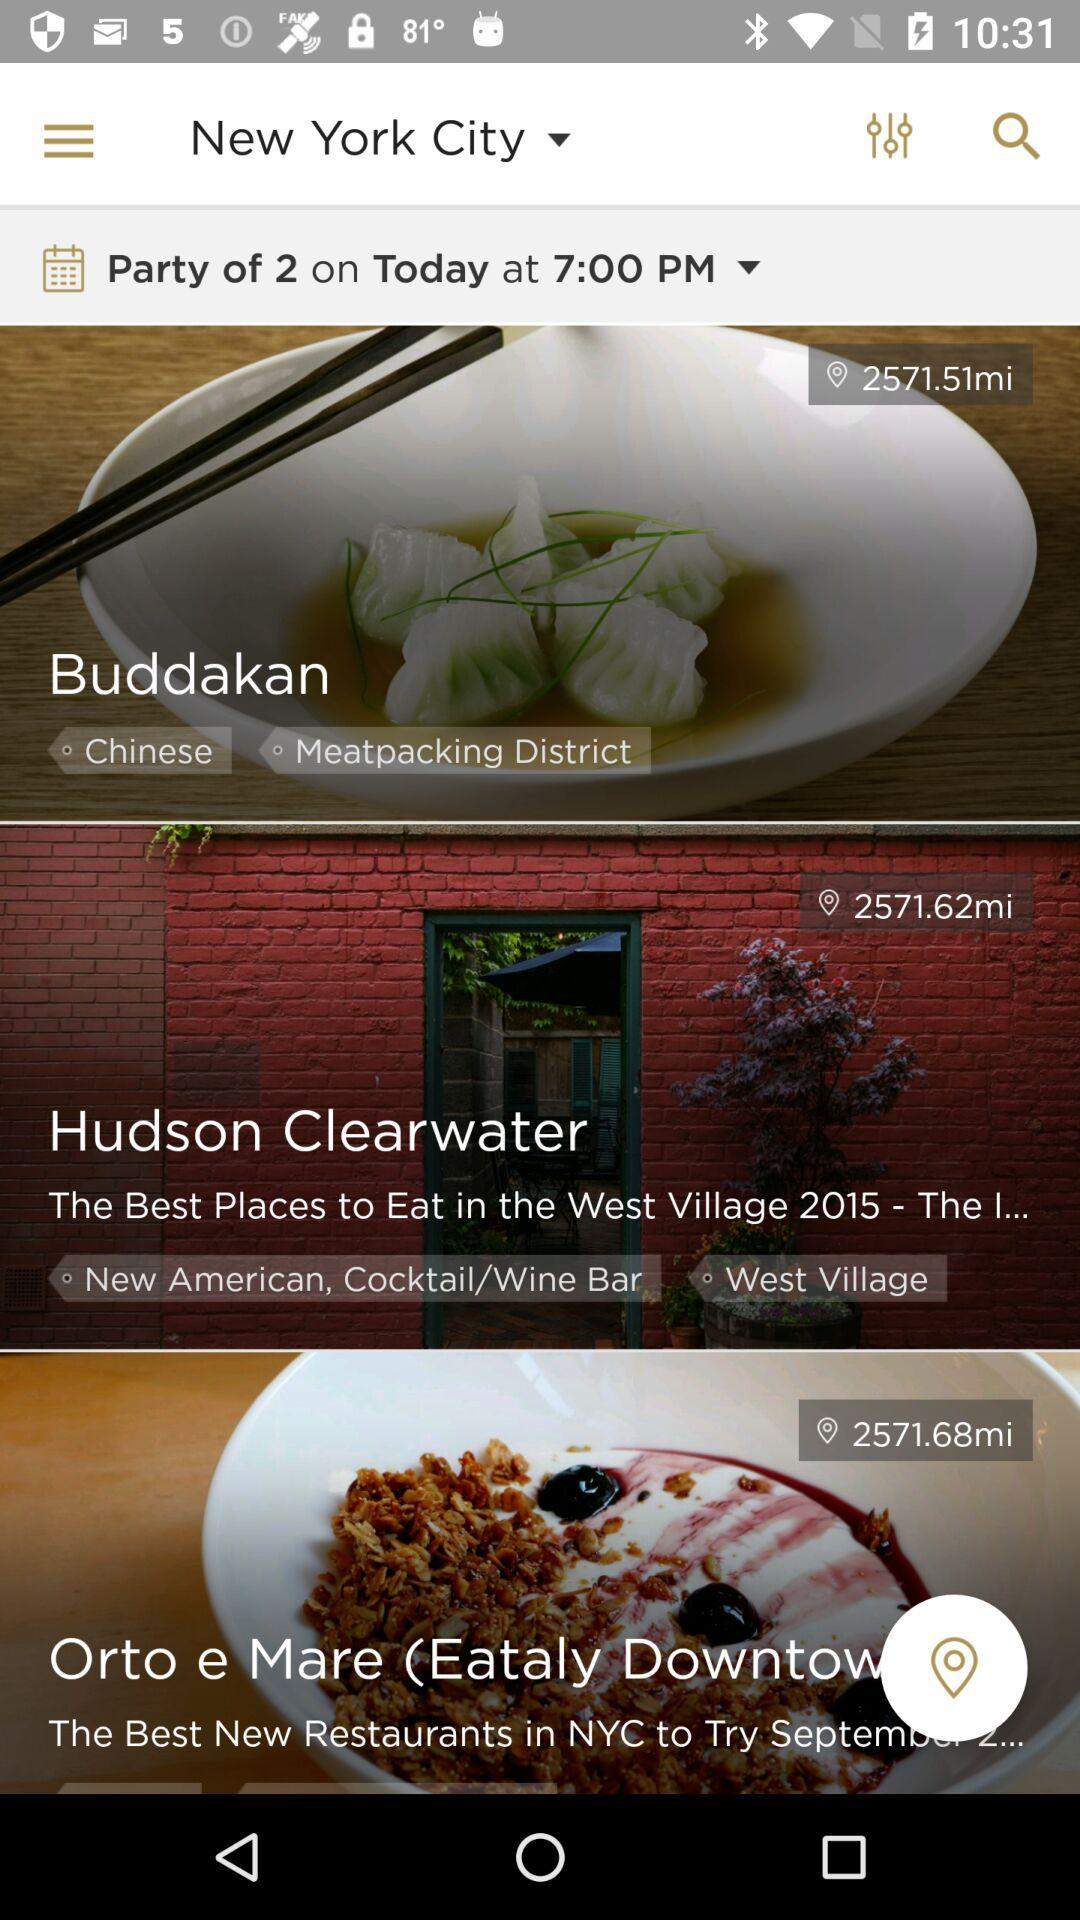How far is "Hudson Clearwater" from the current location? "Hudson Clearwater" is 2571.62 miles away from the current location. 